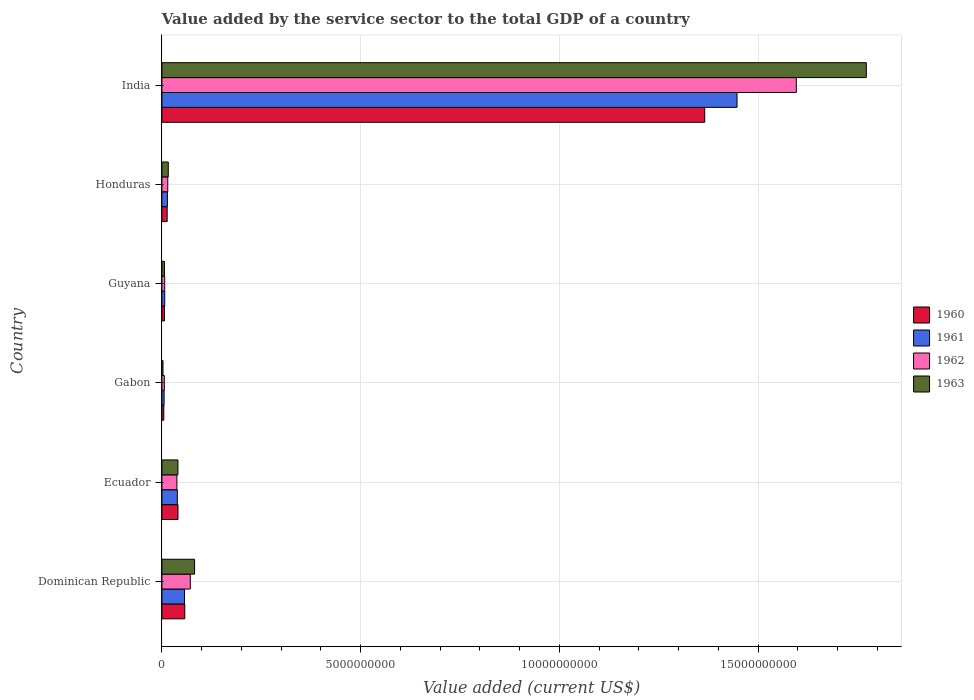How many bars are there on the 5th tick from the top?
Make the answer very short. 4. What is the label of the 4th group of bars from the top?
Offer a very short reply. Gabon. In how many cases, is the number of bars for a given country not equal to the number of legend labels?
Offer a terse response. 0. What is the value added by the service sector to the total GDP in 1963 in Gabon?
Provide a succinct answer. 2.75e+07. Across all countries, what is the maximum value added by the service sector to the total GDP in 1960?
Give a very brief answer. 1.37e+1. Across all countries, what is the minimum value added by the service sector to the total GDP in 1961?
Offer a very short reply. 5.57e+07. In which country was the value added by the service sector to the total GDP in 1960 maximum?
Give a very brief answer. India. In which country was the value added by the service sector to the total GDP in 1960 minimum?
Offer a very short reply. Gabon. What is the total value added by the service sector to the total GDP in 1963 in the graph?
Offer a terse response. 1.92e+1. What is the difference between the value added by the service sector to the total GDP in 1962 in Gabon and that in India?
Make the answer very short. -1.59e+1. What is the difference between the value added by the service sector to the total GDP in 1960 in India and the value added by the service sector to the total GDP in 1963 in Ecuador?
Offer a terse response. 1.33e+1. What is the average value added by the service sector to the total GDP in 1962 per country?
Make the answer very short. 2.89e+09. What is the difference between the value added by the service sector to the total GDP in 1960 and value added by the service sector to the total GDP in 1963 in India?
Offer a terse response. -4.07e+09. In how many countries, is the value added by the service sector to the total GDP in 1963 greater than 17000000000 US$?
Make the answer very short. 1. What is the ratio of the value added by the service sector to the total GDP in 1963 in Dominican Republic to that in Gabon?
Provide a succinct answer. 29.91. Is the value added by the service sector to the total GDP in 1961 in Ecuador less than that in Gabon?
Ensure brevity in your answer.  No. Is the difference between the value added by the service sector to the total GDP in 1960 in Dominican Republic and Guyana greater than the difference between the value added by the service sector to the total GDP in 1963 in Dominican Republic and Guyana?
Your response must be concise. No. What is the difference between the highest and the second highest value added by the service sector to the total GDP in 1963?
Your response must be concise. 1.69e+1. What is the difference between the highest and the lowest value added by the service sector to the total GDP in 1962?
Your answer should be compact. 1.59e+1. In how many countries, is the value added by the service sector to the total GDP in 1960 greater than the average value added by the service sector to the total GDP in 1960 taken over all countries?
Your response must be concise. 1. Is the sum of the value added by the service sector to the total GDP in 1963 in Ecuador and Gabon greater than the maximum value added by the service sector to the total GDP in 1961 across all countries?
Keep it short and to the point. No. What does the 4th bar from the top in Honduras represents?
Offer a terse response. 1960. What does the 1st bar from the bottom in Dominican Republic represents?
Provide a short and direct response. 1960. Are all the bars in the graph horizontal?
Keep it short and to the point. Yes. How many countries are there in the graph?
Offer a very short reply. 6. What is the difference between two consecutive major ticks on the X-axis?
Your answer should be compact. 5.00e+09. Does the graph contain grids?
Give a very brief answer. Yes. Where does the legend appear in the graph?
Your response must be concise. Center right. How many legend labels are there?
Offer a terse response. 4. How are the legend labels stacked?
Provide a succinct answer. Vertical. What is the title of the graph?
Your answer should be compact. Value added by the service sector to the total GDP of a country. What is the label or title of the X-axis?
Make the answer very short. Value added (current US$). What is the Value added (current US$) in 1960 in Dominican Republic?
Provide a short and direct response. 5.76e+08. What is the Value added (current US$) in 1961 in Dominican Republic?
Provide a short and direct response. 5.68e+08. What is the Value added (current US$) in 1962 in Dominican Republic?
Your answer should be very brief. 7.14e+08. What is the Value added (current US$) in 1963 in Dominican Republic?
Your response must be concise. 8.22e+08. What is the Value added (current US$) of 1960 in Ecuador?
Provide a short and direct response. 4.05e+08. What is the Value added (current US$) in 1961 in Ecuador?
Ensure brevity in your answer.  3.88e+08. What is the Value added (current US$) of 1962 in Ecuador?
Keep it short and to the point. 3.77e+08. What is the Value added (current US$) of 1963 in Ecuador?
Ensure brevity in your answer.  4.03e+08. What is the Value added (current US$) of 1960 in Gabon?
Provide a short and direct response. 4.80e+07. What is the Value added (current US$) of 1961 in Gabon?
Offer a very short reply. 5.57e+07. What is the Value added (current US$) in 1962 in Gabon?
Provide a succinct answer. 6.13e+07. What is the Value added (current US$) in 1963 in Gabon?
Keep it short and to the point. 2.75e+07. What is the Value added (current US$) in 1960 in Guyana?
Offer a very short reply. 6.55e+07. What is the Value added (current US$) in 1961 in Guyana?
Offer a very short reply. 7.13e+07. What is the Value added (current US$) of 1962 in Guyana?
Give a very brief answer. 7.03e+07. What is the Value added (current US$) in 1963 in Guyana?
Offer a terse response. 6.42e+07. What is the Value added (current US$) in 1960 in Honduras?
Offer a very short reply. 1.33e+08. What is the Value added (current US$) of 1961 in Honduras?
Make the answer very short. 1.39e+08. What is the Value added (current US$) of 1962 in Honduras?
Make the answer very short. 1.48e+08. What is the Value added (current US$) in 1963 in Honduras?
Your answer should be very brief. 1.60e+08. What is the Value added (current US$) of 1960 in India?
Your answer should be very brief. 1.37e+1. What is the Value added (current US$) of 1961 in India?
Your answer should be compact. 1.45e+1. What is the Value added (current US$) of 1962 in India?
Your response must be concise. 1.60e+1. What is the Value added (current US$) in 1963 in India?
Your answer should be very brief. 1.77e+1. Across all countries, what is the maximum Value added (current US$) of 1960?
Your answer should be compact. 1.37e+1. Across all countries, what is the maximum Value added (current US$) in 1961?
Provide a short and direct response. 1.45e+1. Across all countries, what is the maximum Value added (current US$) in 1962?
Provide a succinct answer. 1.60e+1. Across all countries, what is the maximum Value added (current US$) of 1963?
Provide a succinct answer. 1.77e+1. Across all countries, what is the minimum Value added (current US$) in 1960?
Offer a very short reply. 4.80e+07. Across all countries, what is the minimum Value added (current US$) in 1961?
Ensure brevity in your answer.  5.57e+07. Across all countries, what is the minimum Value added (current US$) of 1962?
Make the answer very short. 6.13e+07. Across all countries, what is the minimum Value added (current US$) of 1963?
Offer a very short reply. 2.75e+07. What is the total Value added (current US$) in 1960 in the graph?
Your answer should be compact. 1.49e+1. What is the total Value added (current US$) of 1961 in the graph?
Your answer should be compact. 1.57e+1. What is the total Value added (current US$) of 1962 in the graph?
Your response must be concise. 1.73e+1. What is the total Value added (current US$) in 1963 in the graph?
Provide a short and direct response. 1.92e+1. What is the difference between the Value added (current US$) of 1960 in Dominican Republic and that in Ecuador?
Offer a very short reply. 1.71e+08. What is the difference between the Value added (current US$) of 1961 in Dominican Republic and that in Ecuador?
Your response must be concise. 1.81e+08. What is the difference between the Value added (current US$) of 1962 in Dominican Republic and that in Ecuador?
Your answer should be very brief. 3.38e+08. What is the difference between the Value added (current US$) of 1963 in Dominican Republic and that in Ecuador?
Make the answer very short. 4.18e+08. What is the difference between the Value added (current US$) in 1960 in Dominican Republic and that in Gabon?
Ensure brevity in your answer.  5.28e+08. What is the difference between the Value added (current US$) of 1961 in Dominican Republic and that in Gabon?
Offer a terse response. 5.13e+08. What is the difference between the Value added (current US$) of 1962 in Dominican Republic and that in Gabon?
Keep it short and to the point. 6.53e+08. What is the difference between the Value added (current US$) of 1963 in Dominican Republic and that in Gabon?
Keep it short and to the point. 7.94e+08. What is the difference between the Value added (current US$) of 1960 in Dominican Republic and that in Guyana?
Your answer should be very brief. 5.10e+08. What is the difference between the Value added (current US$) in 1961 in Dominican Republic and that in Guyana?
Make the answer very short. 4.97e+08. What is the difference between the Value added (current US$) in 1962 in Dominican Republic and that in Guyana?
Ensure brevity in your answer.  6.44e+08. What is the difference between the Value added (current US$) of 1963 in Dominican Republic and that in Guyana?
Offer a very short reply. 7.57e+08. What is the difference between the Value added (current US$) in 1960 in Dominican Republic and that in Honduras?
Keep it short and to the point. 4.43e+08. What is the difference between the Value added (current US$) of 1961 in Dominican Republic and that in Honduras?
Provide a short and direct response. 4.30e+08. What is the difference between the Value added (current US$) of 1962 in Dominican Republic and that in Honduras?
Ensure brevity in your answer.  5.67e+08. What is the difference between the Value added (current US$) of 1963 in Dominican Republic and that in Honduras?
Your answer should be compact. 6.61e+08. What is the difference between the Value added (current US$) in 1960 in Dominican Republic and that in India?
Ensure brevity in your answer.  -1.31e+1. What is the difference between the Value added (current US$) of 1961 in Dominican Republic and that in India?
Give a very brief answer. -1.39e+1. What is the difference between the Value added (current US$) in 1962 in Dominican Republic and that in India?
Keep it short and to the point. -1.52e+1. What is the difference between the Value added (current US$) of 1963 in Dominican Republic and that in India?
Your response must be concise. -1.69e+1. What is the difference between the Value added (current US$) of 1960 in Ecuador and that in Gabon?
Make the answer very short. 3.57e+08. What is the difference between the Value added (current US$) in 1961 in Ecuador and that in Gabon?
Make the answer very short. 3.32e+08. What is the difference between the Value added (current US$) in 1962 in Ecuador and that in Gabon?
Provide a succinct answer. 3.16e+08. What is the difference between the Value added (current US$) of 1963 in Ecuador and that in Gabon?
Your answer should be compact. 3.76e+08. What is the difference between the Value added (current US$) in 1960 in Ecuador and that in Guyana?
Your response must be concise. 3.39e+08. What is the difference between the Value added (current US$) of 1961 in Ecuador and that in Guyana?
Keep it short and to the point. 3.17e+08. What is the difference between the Value added (current US$) in 1962 in Ecuador and that in Guyana?
Provide a short and direct response. 3.07e+08. What is the difference between the Value added (current US$) of 1963 in Ecuador and that in Guyana?
Keep it short and to the point. 3.39e+08. What is the difference between the Value added (current US$) of 1960 in Ecuador and that in Honduras?
Give a very brief answer. 2.72e+08. What is the difference between the Value added (current US$) of 1961 in Ecuador and that in Honduras?
Give a very brief answer. 2.49e+08. What is the difference between the Value added (current US$) of 1962 in Ecuador and that in Honduras?
Offer a very short reply. 2.29e+08. What is the difference between the Value added (current US$) of 1963 in Ecuador and that in Honduras?
Keep it short and to the point. 2.43e+08. What is the difference between the Value added (current US$) in 1960 in Ecuador and that in India?
Offer a very short reply. -1.33e+1. What is the difference between the Value added (current US$) in 1961 in Ecuador and that in India?
Your response must be concise. -1.41e+1. What is the difference between the Value added (current US$) of 1962 in Ecuador and that in India?
Your response must be concise. -1.56e+1. What is the difference between the Value added (current US$) in 1963 in Ecuador and that in India?
Ensure brevity in your answer.  -1.73e+1. What is the difference between the Value added (current US$) of 1960 in Gabon and that in Guyana?
Offer a terse response. -1.76e+07. What is the difference between the Value added (current US$) of 1961 in Gabon and that in Guyana?
Offer a very short reply. -1.56e+07. What is the difference between the Value added (current US$) of 1962 in Gabon and that in Guyana?
Give a very brief answer. -9.03e+06. What is the difference between the Value added (current US$) of 1963 in Gabon and that in Guyana?
Give a very brief answer. -3.68e+07. What is the difference between the Value added (current US$) in 1960 in Gabon and that in Honduras?
Give a very brief answer. -8.46e+07. What is the difference between the Value added (current US$) in 1961 in Gabon and that in Honduras?
Your answer should be very brief. -8.31e+07. What is the difference between the Value added (current US$) of 1962 in Gabon and that in Honduras?
Offer a terse response. -8.64e+07. What is the difference between the Value added (current US$) of 1963 in Gabon and that in Honduras?
Provide a succinct answer. -1.33e+08. What is the difference between the Value added (current US$) in 1960 in Gabon and that in India?
Ensure brevity in your answer.  -1.36e+1. What is the difference between the Value added (current US$) of 1961 in Gabon and that in India?
Your answer should be very brief. -1.44e+1. What is the difference between the Value added (current US$) of 1962 in Gabon and that in India?
Provide a succinct answer. -1.59e+1. What is the difference between the Value added (current US$) of 1963 in Gabon and that in India?
Your answer should be very brief. -1.77e+1. What is the difference between the Value added (current US$) of 1960 in Guyana and that in Honduras?
Your answer should be compact. -6.71e+07. What is the difference between the Value added (current US$) of 1961 in Guyana and that in Honduras?
Your answer should be compact. -6.74e+07. What is the difference between the Value added (current US$) in 1962 in Guyana and that in Honduras?
Your answer should be very brief. -7.74e+07. What is the difference between the Value added (current US$) of 1963 in Guyana and that in Honduras?
Keep it short and to the point. -9.62e+07. What is the difference between the Value added (current US$) in 1960 in Guyana and that in India?
Offer a very short reply. -1.36e+1. What is the difference between the Value added (current US$) in 1961 in Guyana and that in India?
Provide a succinct answer. -1.44e+1. What is the difference between the Value added (current US$) of 1962 in Guyana and that in India?
Offer a terse response. -1.59e+1. What is the difference between the Value added (current US$) of 1963 in Guyana and that in India?
Make the answer very short. -1.77e+1. What is the difference between the Value added (current US$) in 1960 in Honduras and that in India?
Ensure brevity in your answer.  -1.35e+1. What is the difference between the Value added (current US$) in 1961 in Honduras and that in India?
Offer a very short reply. -1.43e+1. What is the difference between the Value added (current US$) of 1962 in Honduras and that in India?
Provide a short and direct response. -1.58e+1. What is the difference between the Value added (current US$) of 1963 in Honduras and that in India?
Your answer should be very brief. -1.76e+1. What is the difference between the Value added (current US$) in 1960 in Dominican Republic and the Value added (current US$) in 1961 in Ecuador?
Offer a very short reply. 1.88e+08. What is the difference between the Value added (current US$) in 1960 in Dominican Republic and the Value added (current US$) in 1962 in Ecuador?
Provide a short and direct response. 1.99e+08. What is the difference between the Value added (current US$) in 1960 in Dominican Republic and the Value added (current US$) in 1963 in Ecuador?
Make the answer very short. 1.73e+08. What is the difference between the Value added (current US$) in 1961 in Dominican Republic and the Value added (current US$) in 1962 in Ecuador?
Provide a short and direct response. 1.92e+08. What is the difference between the Value added (current US$) in 1961 in Dominican Republic and the Value added (current US$) in 1963 in Ecuador?
Your response must be concise. 1.65e+08. What is the difference between the Value added (current US$) of 1962 in Dominican Republic and the Value added (current US$) of 1963 in Ecuador?
Make the answer very short. 3.11e+08. What is the difference between the Value added (current US$) in 1960 in Dominican Republic and the Value added (current US$) in 1961 in Gabon?
Provide a succinct answer. 5.20e+08. What is the difference between the Value added (current US$) of 1960 in Dominican Republic and the Value added (current US$) of 1962 in Gabon?
Provide a short and direct response. 5.15e+08. What is the difference between the Value added (current US$) in 1960 in Dominican Republic and the Value added (current US$) in 1963 in Gabon?
Make the answer very short. 5.49e+08. What is the difference between the Value added (current US$) of 1961 in Dominican Republic and the Value added (current US$) of 1962 in Gabon?
Give a very brief answer. 5.07e+08. What is the difference between the Value added (current US$) in 1961 in Dominican Republic and the Value added (current US$) in 1963 in Gabon?
Ensure brevity in your answer.  5.41e+08. What is the difference between the Value added (current US$) of 1962 in Dominican Republic and the Value added (current US$) of 1963 in Gabon?
Your response must be concise. 6.87e+08. What is the difference between the Value added (current US$) of 1960 in Dominican Republic and the Value added (current US$) of 1961 in Guyana?
Keep it short and to the point. 5.05e+08. What is the difference between the Value added (current US$) in 1960 in Dominican Republic and the Value added (current US$) in 1962 in Guyana?
Your answer should be compact. 5.06e+08. What is the difference between the Value added (current US$) in 1960 in Dominican Republic and the Value added (current US$) in 1963 in Guyana?
Offer a very short reply. 5.12e+08. What is the difference between the Value added (current US$) of 1961 in Dominican Republic and the Value added (current US$) of 1962 in Guyana?
Give a very brief answer. 4.98e+08. What is the difference between the Value added (current US$) in 1961 in Dominican Republic and the Value added (current US$) in 1963 in Guyana?
Give a very brief answer. 5.04e+08. What is the difference between the Value added (current US$) of 1962 in Dominican Republic and the Value added (current US$) of 1963 in Guyana?
Ensure brevity in your answer.  6.50e+08. What is the difference between the Value added (current US$) of 1960 in Dominican Republic and the Value added (current US$) of 1961 in Honduras?
Ensure brevity in your answer.  4.37e+08. What is the difference between the Value added (current US$) in 1960 in Dominican Republic and the Value added (current US$) in 1962 in Honduras?
Offer a very short reply. 4.28e+08. What is the difference between the Value added (current US$) in 1960 in Dominican Republic and the Value added (current US$) in 1963 in Honduras?
Ensure brevity in your answer.  4.16e+08. What is the difference between the Value added (current US$) in 1961 in Dominican Republic and the Value added (current US$) in 1962 in Honduras?
Give a very brief answer. 4.21e+08. What is the difference between the Value added (current US$) of 1961 in Dominican Republic and the Value added (current US$) of 1963 in Honduras?
Provide a succinct answer. 4.08e+08. What is the difference between the Value added (current US$) in 1962 in Dominican Republic and the Value added (current US$) in 1963 in Honduras?
Ensure brevity in your answer.  5.54e+08. What is the difference between the Value added (current US$) of 1960 in Dominican Republic and the Value added (current US$) of 1961 in India?
Ensure brevity in your answer.  -1.39e+1. What is the difference between the Value added (current US$) in 1960 in Dominican Republic and the Value added (current US$) in 1962 in India?
Keep it short and to the point. -1.54e+1. What is the difference between the Value added (current US$) in 1960 in Dominican Republic and the Value added (current US$) in 1963 in India?
Give a very brief answer. -1.71e+1. What is the difference between the Value added (current US$) of 1961 in Dominican Republic and the Value added (current US$) of 1962 in India?
Your answer should be compact. -1.54e+1. What is the difference between the Value added (current US$) in 1961 in Dominican Republic and the Value added (current US$) in 1963 in India?
Keep it short and to the point. -1.72e+1. What is the difference between the Value added (current US$) in 1962 in Dominican Republic and the Value added (current US$) in 1963 in India?
Make the answer very short. -1.70e+1. What is the difference between the Value added (current US$) of 1960 in Ecuador and the Value added (current US$) of 1961 in Gabon?
Provide a succinct answer. 3.49e+08. What is the difference between the Value added (current US$) of 1960 in Ecuador and the Value added (current US$) of 1962 in Gabon?
Offer a very short reply. 3.44e+08. What is the difference between the Value added (current US$) in 1960 in Ecuador and the Value added (current US$) in 1963 in Gabon?
Your answer should be very brief. 3.77e+08. What is the difference between the Value added (current US$) in 1961 in Ecuador and the Value added (current US$) in 1962 in Gabon?
Your answer should be compact. 3.27e+08. What is the difference between the Value added (current US$) of 1961 in Ecuador and the Value added (current US$) of 1963 in Gabon?
Your answer should be very brief. 3.60e+08. What is the difference between the Value added (current US$) in 1962 in Ecuador and the Value added (current US$) in 1963 in Gabon?
Keep it short and to the point. 3.49e+08. What is the difference between the Value added (current US$) of 1960 in Ecuador and the Value added (current US$) of 1961 in Guyana?
Provide a short and direct response. 3.34e+08. What is the difference between the Value added (current US$) of 1960 in Ecuador and the Value added (current US$) of 1962 in Guyana?
Give a very brief answer. 3.35e+08. What is the difference between the Value added (current US$) of 1960 in Ecuador and the Value added (current US$) of 1963 in Guyana?
Provide a succinct answer. 3.41e+08. What is the difference between the Value added (current US$) of 1961 in Ecuador and the Value added (current US$) of 1962 in Guyana?
Your answer should be very brief. 3.18e+08. What is the difference between the Value added (current US$) in 1961 in Ecuador and the Value added (current US$) in 1963 in Guyana?
Give a very brief answer. 3.24e+08. What is the difference between the Value added (current US$) of 1962 in Ecuador and the Value added (current US$) of 1963 in Guyana?
Your answer should be very brief. 3.13e+08. What is the difference between the Value added (current US$) of 1960 in Ecuador and the Value added (current US$) of 1961 in Honduras?
Keep it short and to the point. 2.66e+08. What is the difference between the Value added (current US$) in 1960 in Ecuador and the Value added (current US$) in 1962 in Honduras?
Your answer should be compact. 2.57e+08. What is the difference between the Value added (current US$) in 1960 in Ecuador and the Value added (current US$) in 1963 in Honduras?
Ensure brevity in your answer.  2.44e+08. What is the difference between the Value added (current US$) in 1961 in Ecuador and the Value added (current US$) in 1962 in Honduras?
Your response must be concise. 2.40e+08. What is the difference between the Value added (current US$) of 1961 in Ecuador and the Value added (current US$) of 1963 in Honduras?
Offer a terse response. 2.28e+08. What is the difference between the Value added (current US$) of 1962 in Ecuador and the Value added (current US$) of 1963 in Honduras?
Your answer should be compact. 2.17e+08. What is the difference between the Value added (current US$) in 1960 in Ecuador and the Value added (current US$) in 1961 in India?
Offer a terse response. -1.41e+1. What is the difference between the Value added (current US$) in 1960 in Ecuador and the Value added (current US$) in 1962 in India?
Make the answer very short. -1.56e+1. What is the difference between the Value added (current US$) in 1960 in Ecuador and the Value added (current US$) in 1963 in India?
Ensure brevity in your answer.  -1.73e+1. What is the difference between the Value added (current US$) of 1961 in Ecuador and the Value added (current US$) of 1962 in India?
Keep it short and to the point. -1.56e+1. What is the difference between the Value added (current US$) in 1961 in Ecuador and the Value added (current US$) in 1963 in India?
Your answer should be compact. -1.73e+1. What is the difference between the Value added (current US$) in 1962 in Ecuador and the Value added (current US$) in 1963 in India?
Your answer should be very brief. -1.73e+1. What is the difference between the Value added (current US$) in 1960 in Gabon and the Value added (current US$) in 1961 in Guyana?
Make the answer very short. -2.34e+07. What is the difference between the Value added (current US$) in 1960 in Gabon and the Value added (current US$) in 1962 in Guyana?
Provide a short and direct response. -2.23e+07. What is the difference between the Value added (current US$) of 1960 in Gabon and the Value added (current US$) of 1963 in Guyana?
Your answer should be compact. -1.63e+07. What is the difference between the Value added (current US$) of 1961 in Gabon and the Value added (current US$) of 1962 in Guyana?
Ensure brevity in your answer.  -1.46e+07. What is the difference between the Value added (current US$) in 1961 in Gabon and the Value added (current US$) in 1963 in Guyana?
Your response must be concise. -8.53e+06. What is the difference between the Value added (current US$) in 1962 in Gabon and the Value added (current US$) in 1963 in Guyana?
Provide a succinct answer. -2.96e+06. What is the difference between the Value added (current US$) in 1960 in Gabon and the Value added (current US$) in 1961 in Honduras?
Give a very brief answer. -9.08e+07. What is the difference between the Value added (current US$) of 1960 in Gabon and the Value added (current US$) of 1962 in Honduras?
Offer a very short reply. -9.97e+07. What is the difference between the Value added (current US$) in 1960 in Gabon and the Value added (current US$) in 1963 in Honduras?
Ensure brevity in your answer.  -1.12e+08. What is the difference between the Value added (current US$) of 1961 in Gabon and the Value added (current US$) of 1962 in Honduras?
Offer a very short reply. -9.20e+07. What is the difference between the Value added (current US$) of 1961 in Gabon and the Value added (current US$) of 1963 in Honduras?
Ensure brevity in your answer.  -1.05e+08. What is the difference between the Value added (current US$) in 1962 in Gabon and the Value added (current US$) in 1963 in Honduras?
Provide a succinct answer. -9.92e+07. What is the difference between the Value added (current US$) in 1960 in Gabon and the Value added (current US$) in 1961 in India?
Offer a terse response. -1.44e+1. What is the difference between the Value added (current US$) in 1960 in Gabon and the Value added (current US$) in 1962 in India?
Give a very brief answer. -1.59e+1. What is the difference between the Value added (current US$) of 1960 in Gabon and the Value added (current US$) of 1963 in India?
Your answer should be very brief. -1.77e+1. What is the difference between the Value added (current US$) of 1961 in Gabon and the Value added (current US$) of 1962 in India?
Offer a very short reply. -1.59e+1. What is the difference between the Value added (current US$) of 1961 in Gabon and the Value added (current US$) of 1963 in India?
Keep it short and to the point. -1.77e+1. What is the difference between the Value added (current US$) of 1962 in Gabon and the Value added (current US$) of 1963 in India?
Provide a succinct answer. -1.77e+1. What is the difference between the Value added (current US$) of 1960 in Guyana and the Value added (current US$) of 1961 in Honduras?
Your answer should be very brief. -7.32e+07. What is the difference between the Value added (current US$) in 1960 in Guyana and the Value added (current US$) in 1962 in Honduras?
Give a very brief answer. -8.21e+07. What is the difference between the Value added (current US$) in 1960 in Guyana and the Value added (current US$) in 1963 in Honduras?
Your answer should be compact. -9.49e+07. What is the difference between the Value added (current US$) in 1961 in Guyana and the Value added (current US$) in 1962 in Honduras?
Make the answer very short. -7.63e+07. What is the difference between the Value added (current US$) in 1961 in Guyana and the Value added (current US$) in 1963 in Honduras?
Your answer should be very brief. -8.91e+07. What is the difference between the Value added (current US$) of 1962 in Guyana and the Value added (current US$) of 1963 in Honduras?
Ensure brevity in your answer.  -9.02e+07. What is the difference between the Value added (current US$) of 1960 in Guyana and the Value added (current US$) of 1961 in India?
Keep it short and to the point. -1.44e+1. What is the difference between the Value added (current US$) in 1960 in Guyana and the Value added (current US$) in 1962 in India?
Your answer should be compact. -1.59e+1. What is the difference between the Value added (current US$) in 1960 in Guyana and the Value added (current US$) in 1963 in India?
Your answer should be compact. -1.77e+1. What is the difference between the Value added (current US$) in 1961 in Guyana and the Value added (current US$) in 1962 in India?
Provide a succinct answer. -1.59e+1. What is the difference between the Value added (current US$) of 1961 in Guyana and the Value added (current US$) of 1963 in India?
Your answer should be compact. -1.76e+1. What is the difference between the Value added (current US$) of 1962 in Guyana and the Value added (current US$) of 1963 in India?
Make the answer very short. -1.77e+1. What is the difference between the Value added (current US$) in 1960 in Honduras and the Value added (current US$) in 1961 in India?
Give a very brief answer. -1.43e+1. What is the difference between the Value added (current US$) in 1960 in Honduras and the Value added (current US$) in 1962 in India?
Give a very brief answer. -1.58e+1. What is the difference between the Value added (current US$) of 1960 in Honduras and the Value added (current US$) of 1963 in India?
Provide a succinct answer. -1.76e+1. What is the difference between the Value added (current US$) of 1961 in Honduras and the Value added (current US$) of 1962 in India?
Make the answer very short. -1.58e+1. What is the difference between the Value added (current US$) of 1961 in Honduras and the Value added (current US$) of 1963 in India?
Keep it short and to the point. -1.76e+1. What is the difference between the Value added (current US$) of 1962 in Honduras and the Value added (current US$) of 1963 in India?
Your answer should be compact. -1.76e+1. What is the average Value added (current US$) in 1960 per country?
Give a very brief answer. 2.48e+09. What is the average Value added (current US$) of 1961 per country?
Provide a succinct answer. 2.62e+09. What is the average Value added (current US$) in 1962 per country?
Your answer should be compact. 2.89e+09. What is the average Value added (current US$) in 1963 per country?
Your response must be concise. 3.20e+09. What is the difference between the Value added (current US$) of 1960 and Value added (current US$) of 1961 in Dominican Republic?
Provide a short and direct response. 7.50e+06. What is the difference between the Value added (current US$) of 1960 and Value added (current US$) of 1962 in Dominican Republic?
Your response must be concise. -1.39e+08. What is the difference between the Value added (current US$) of 1960 and Value added (current US$) of 1963 in Dominican Republic?
Give a very brief answer. -2.46e+08. What is the difference between the Value added (current US$) of 1961 and Value added (current US$) of 1962 in Dominican Republic?
Ensure brevity in your answer.  -1.46e+08. What is the difference between the Value added (current US$) in 1961 and Value added (current US$) in 1963 in Dominican Republic?
Make the answer very short. -2.53e+08. What is the difference between the Value added (current US$) of 1962 and Value added (current US$) of 1963 in Dominican Republic?
Offer a very short reply. -1.07e+08. What is the difference between the Value added (current US$) in 1960 and Value added (current US$) in 1961 in Ecuador?
Your response must be concise. 1.69e+07. What is the difference between the Value added (current US$) in 1960 and Value added (current US$) in 1962 in Ecuador?
Make the answer very short. 2.79e+07. What is the difference between the Value added (current US$) in 1960 and Value added (current US$) in 1963 in Ecuador?
Provide a succinct answer. 1.47e+06. What is the difference between the Value added (current US$) of 1961 and Value added (current US$) of 1962 in Ecuador?
Your response must be concise. 1.10e+07. What is the difference between the Value added (current US$) of 1961 and Value added (current US$) of 1963 in Ecuador?
Provide a short and direct response. -1.54e+07. What is the difference between the Value added (current US$) of 1962 and Value added (current US$) of 1963 in Ecuador?
Make the answer very short. -2.64e+07. What is the difference between the Value added (current US$) in 1960 and Value added (current US$) in 1961 in Gabon?
Your answer should be compact. -7.74e+06. What is the difference between the Value added (current US$) of 1960 and Value added (current US$) of 1962 in Gabon?
Provide a succinct answer. -1.33e+07. What is the difference between the Value added (current US$) of 1960 and Value added (current US$) of 1963 in Gabon?
Offer a very short reply. 2.05e+07. What is the difference between the Value added (current US$) of 1961 and Value added (current US$) of 1962 in Gabon?
Give a very brief answer. -5.57e+06. What is the difference between the Value added (current US$) of 1961 and Value added (current US$) of 1963 in Gabon?
Provide a succinct answer. 2.82e+07. What is the difference between the Value added (current US$) in 1962 and Value added (current US$) in 1963 in Gabon?
Keep it short and to the point. 3.38e+07. What is the difference between the Value added (current US$) in 1960 and Value added (current US$) in 1961 in Guyana?
Your response must be concise. -5.83e+06. What is the difference between the Value added (current US$) in 1960 and Value added (current US$) in 1962 in Guyana?
Offer a terse response. -4.78e+06. What is the difference between the Value added (current US$) in 1960 and Value added (current US$) in 1963 in Guyana?
Offer a terse response. 1.28e+06. What is the difference between the Value added (current US$) of 1961 and Value added (current US$) of 1962 in Guyana?
Keep it short and to the point. 1.05e+06. What is the difference between the Value added (current US$) of 1961 and Value added (current US$) of 1963 in Guyana?
Your response must be concise. 7.12e+06. What is the difference between the Value added (current US$) of 1962 and Value added (current US$) of 1963 in Guyana?
Offer a terse response. 6.07e+06. What is the difference between the Value added (current US$) of 1960 and Value added (current US$) of 1961 in Honduras?
Your answer should be very brief. -6.15e+06. What is the difference between the Value added (current US$) of 1960 and Value added (current US$) of 1962 in Honduras?
Your answer should be very brief. -1.50e+07. What is the difference between the Value added (current US$) in 1960 and Value added (current US$) in 1963 in Honduras?
Offer a very short reply. -2.78e+07. What is the difference between the Value added (current US$) of 1961 and Value added (current US$) of 1962 in Honduras?
Your response must be concise. -8.90e+06. What is the difference between the Value added (current US$) of 1961 and Value added (current US$) of 1963 in Honduras?
Your answer should be very brief. -2.17e+07. What is the difference between the Value added (current US$) in 1962 and Value added (current US$) in 1963 in Honduras?
Give a very brief answer. -1.28e+07. What is the difference between the Value added (current US$) of 1960 and Value added (current US$) of 1961 in India?
Give a very brief answer. -8.13e+08. What is the difference between the Value added (current US$) of 1960 and Value added (current US$) of 1962 in India?
Your answer should be compact. -2.30e+09. What is the difference between the Value added (current US$) in 1960 and Value added (current US$) in 1963 in India?
Your answer should be very brief. -4.07e+09. What is the difference between the Value added (current US$) of 1961 and Value added (current US$) of 1962 in India?
Provide a short and direct response. -1.49e+09. What is the difference between the Value added (current US$) in 1961 and Value added (current US$) in 1963 in India?
Your response must be concise. -3.25e+09. What is the difference between the Value added (current US$) of 1962 and Value added (current US$) of 1963 in India?
Provide a succinct answer. -1.76e+09. What is the ratio of the Value added (current US$) in 1960 in Dominican Republic to that in Ecuador?
Your answer should be very brief. 1.42. What is the ratio of the Value added (current US$) in 1961 in Dominican Republic to that in Ecuador?
Your response must be concise. 1.47. What is the ratio of the Value added (current US$) of 1962 in Dominican Republic to that in Ecuador?
Offer a terse response. 1.9. What is the ratio of the Value added (current US$) in 1963 in Dominican Republic to that in Ecuador?
Give a very brief answer. 2.04. What is the ratio of the Value added (current US$) of 1960 in Dominican Republic to that in Gabon?
Make the answer very short. 12.01. What is the ratio of the Value added (current US$) of 1961 in Dominican Republic to that in Gabon?
Keep it short and to the point. 10.21. What is the ratio of the Value added (current US$) in 1962 in Dominican Republic to that in Gabon?
Provide a succinct answer. 11.66. What is the ratio of the Value added (current US$) in 1963 in Dominican Republic to that in Gabon?
Give a very brief answer. 29.91. What is the ratio of the Value added (current US$) of 1960 in Dominican Republic to that in Guyana?
Offer a terse response. 8.79. What is the ratio of the Value added (current US$) of 1961 in Dominican Republic to that in Guyana?
Your answer should be compact. 7.97. What is the ratio of the Value added (current US$) in 1962 in Dominican Republic to that in Guyana?
Ensure brevity in your answer.  10.16. What is the ratio of the Value added (current US$) of 1963 in Dominican Republic to that in Guyana?
Make the answer very short. 12.79. What is the ratio of the Value added (current US$) of 1960 in Dominican Republic to that in Honduras?
Your response must be concise. 4.34. What is the ratio of the Value added (current US$) of 1961 in Dominican Republic to that in Honduras?
Give a very brief answer. 4.1. What is the ratio of the Value added (current US$) in 1962 in Dominican Republic to that in Honduras?
Your answer should be compact. 4.84. What is the ratio of the Value added (current US$) in 1963 in Dominican Republic to that in Honduras?
Give a very brief answer. 5.12. What is the ratio of the Value added (current US$) in 1960 in Dominican Republic to that in India?
Your response must be concise. 0.04. What is the ratio of the Value added (current US$) of 1961 in Dominican Republic to that in India?
Your answer should be compact. 0.04. What is the ratio of the Value added (current US$) of 1962 in Dominican Republic to that in India?
Give a very brief answer. 0.04. What is the ratio of the Value added (current US$) of 1963 in Dominican Republic to that in India?
Your answer should be compact. 0.05. What is the ratio of the Value added (current US$) in 1960 in Ecuador to that in Gabon?
Offer a terse response. 8.44. What is the ratio of the Value added (current US$) of 1961 in Ecuador to that in Gabon?
Provide a short and direct response. 6.97. What is the ratio of the Value added (current US$) of 1962 in Ecuador to that in Gabon?
Provide a succinct answer. 6.15. What is the ratio of the Value added (current US$) of 1963 in Ecuador to that in Gabon?
Your response must be concise. 14.68. What is the ratio of the Value added (current US$) in 1960 in Ecuador to that in Guyana?
Your answer should be compact. 6.18. What is the ratio of the Value added (current US$) of 1961 in Ecuador to that in Guyana?
Give a very brief answer. 5.44. What is the ratio of the Value added (current US$) of 1962 in Ecuador to that in Guyana?
Your answer should be very brief. 5.36. What is the ratio of the Value added (current US$) of 1963 in Ecuador to that in Guyana?
Ensure brevity in your answer.  6.28. What is the ratio of the Value added (current US$) of 1960 in Ecuador to that in Honduras?
Offer a very short reply. 3.05. What is the ratio of the Value added (current US$) of 1961 in Ecuador to that in Honduras?
Provide a short and direct response. 2.8. What is the ratio of the Value added (current US$) in 1962 in Ecuador to that in Honduras?
Keep it short and to the point. 2.55. What is the ratio of the Value added (current US$) in 1963 in Ecuador to that in Honduras?
Offer a very short reply. 2.51. What is the ratio of the Value added (current US$) of 1960 in Ecuador to that in India?
Give a very brief answer. 0.03. What is the ratio of the Value added (current US$) of 1961 in Ecuador to that in India?
Ensure brevity in your answer.  0.03. What is the ratio of the Value added (current US$) in 1962 in Ecuador to that in India?
Offer a terse response. 0.02. What is the ratio of the Value added (current US$) of 1963 in Ecuador to that in India?
Make the answer very short. 0.02. What is the ratio of the Value added (current US$) of 1960 in Gabon to that in Guyana?
Ensure brevity in your answer.  0.73. What is the ratio of the Value added (current US$) of 1961 in Gabon to that in Guyana?
Provide a short and direct response. 0.78. What is the ratio of the Value added (current US$) in 1962 in Gabon to that in Guyana?
Provide a succinct answer. 0.87. What is the ratio of the Value added (current US$) of 1963 in Gabon to that in Guyana?
Your answer should be compact. 0.43. What is the ratio of the Value added (current US$) of 1960 in Gabon to that in Honduras?
Offer a terse response. 0.36. What is the ratio of the Value added (current US$) of 1961 in Gabon to that in Honduras?
Your response must be concise. 0.4. What is the ratio of the Value added (current US$) in 1962 in Gabon to that in Honduras?
Make the answer very short. 0.41. What is the ratio of the Value added (current US$) of 1963 in Gabon to that in Honduras?
Provide a succinct answer. 0.17. What is the ratio of the Value added (current US$) in 1960 in Gabon to that in India?
Your response must be concise. 0. What is the ratio of the Value added (current US$) in 1961 in Gabon to that in India?
Make the answer very short. 0. What is the ratio of the Value added (current US$) of 1962 in Gabon to that in India?
Offer a terse response. 0. What is the ratio of the Value added (current US$) in 1963 in Gabon to that in India?
Your response must be concise. 0. What is the ratio of the Value added (current US$) in 1960 in Guyana to that in Honduras?
Provide a short and direct response. 0.49. What is the ratio of the Value added (current US$) in 1961 in Guyana to that in Honduras?
Provide a short and direct response. 0.51. What is the ratio of the Value added (current US$) in 1962 in Guyana to that in Honduras?
Give a very brief answer. 0.48. What is the ratio of the Value added (current US$) in 1963 in Guyana to that in Honduras?
Offer a very short reply. 0.4. What is the ratio of the Value added (current US$) of 1960 in Guyana to that in India?
Make the answer very short. 0. What is the ratio of the Value added (current US$) in 1961 in Guyana to that in India?
Make the answer very short. 0. What is the ratio of the Value added (current US$) of 1962 in Guyana to that in India?
Ensure brevity in your answer.  0. What is the ratio of the Value added (current US$) of 1963 in Guyana to that in India?
Make the answer very short. 0. What is the ratio of the Value added (current US$) of 1960 in Honduras to that in India?
Ensure brevity in your answer.  0.01. What is the ratio of the Value added (current US$) in 1961 in Honduras to that in India?
Offer a very short reply. 0.01. What is the ratio of the Value added (current US$) in 1962 in Honduras to that in India?
Give a very brief answer. 0.01. What is the ratio of the Value added (current US$) of 1963 in Honduras to that in India?
Make the answer very short. 0.01. What is the difference between the highest and the second highest Value added (current US$) of 1960?
Offer a terse response. 1.31e+1. What is the difference between the highest and the second highest Value added (current US$) in 1961?
Your answer should be very brief. 1.39e+1. What is the difference between the highest and the second highest Value added (current US$) of 1962?
Your answer should be very brief. 1.52e+1. What is the difference between the highest and the second highest Value added (current US$) of 1963?
Provide a succinct answer. 1.69e+1. What is the difference between the highest and the lowest Value added (current US$) of 1960?
Give a very brief answer. 1.36e+1. What is the difference between the highest and the lowest Value added (current US$) in 1961?
Make the answer very short. 1.44e+1. What is the difference between the highest and the lowest Value added (current US$) of 1962?
Give a very brief answer. 1.59e+1. What is the difference between the highest and the lowest Value added (current US$) of 1963?
Offer a very short reply. 1.77e+1. 